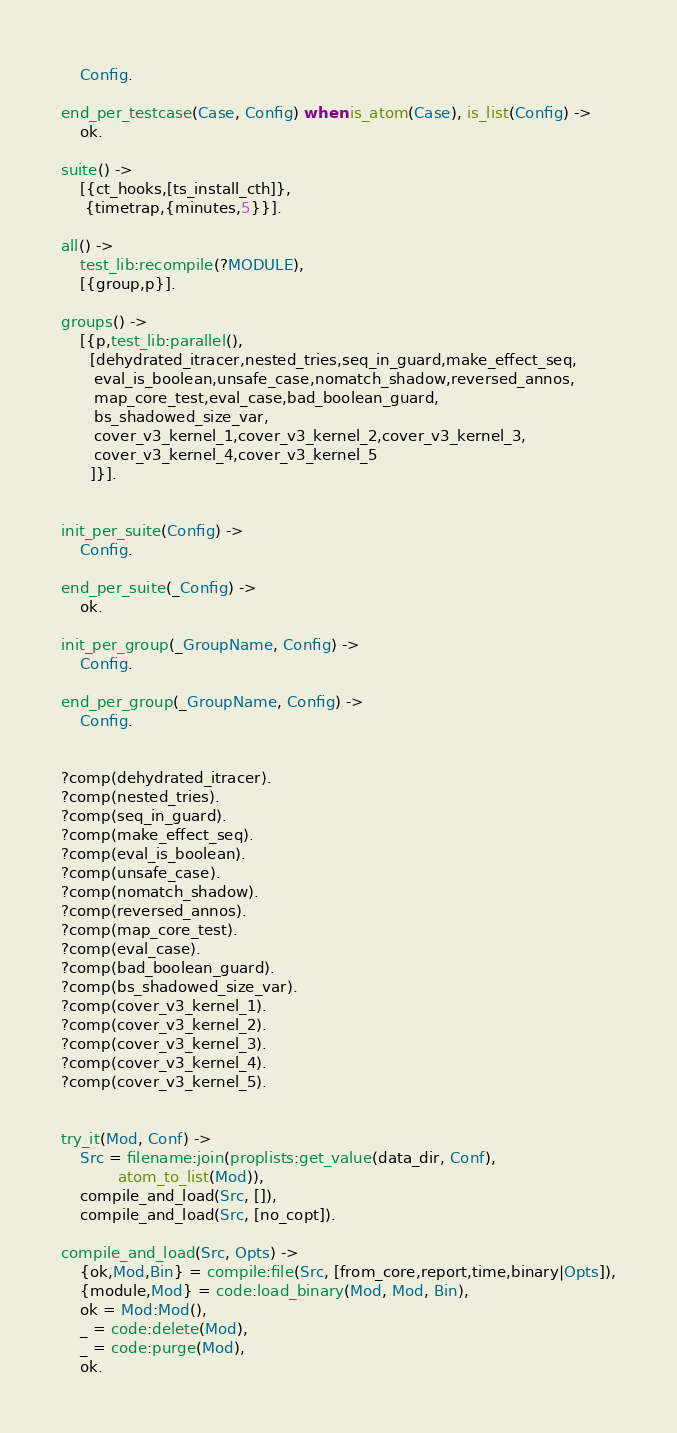Convert code to text. <code><loc_0><loc_0><loc_500><loc_500><_Erlang_>    Config.

end_per_testcase(Case, Config) when is_atom(Case), is_list(Config) ->
    ok.

suite() ->
    [{ct_hooks,[ts_install_cth]},
     {timetrap,{minutes,5}}].

all() -> 
    test_lib:recompile(?MODULE),
    [{group,p}].

groups() -> 
    [{p,test_lib:parallel(),
      [dehydrated_itracer,nested_tries,seq_in_guard,make_effect_seq,
       eval_is_boolean,unsafe_case,nomatch_shadow,reversed_annos,
       map_core_test,eval_case,bad_boolean_guard,
       bs_shadowed_size_var,
       cover_v3_kernel_1,cover_v3_kernel_2,cover_v3_kernel_3,
       cover_v3_kernel_4,cover_v3_kernel_5
      ]}].


init_per_suite(Config) ->
    Config.

end_per_suite(_Config) ->
    ok.

init_per_group(_GroupName, Config) ->
    Config.

end_per_group(_GroupName, Config) ->
    Config.


?comp(dehydrated_itracer).
?comp(nested_tries).
?comp(seq_in_guard).
?comp(make_effect_seq).
?comp(eval_is_boolean).
?comp(unsafe_case).
?comp(nomatch_shadow).
?comp(reversed_annos).
?comp(map_core_test).
?comp(eval_case).
?comp(bad_boolean_guard).
?comp(bs_shadowed_size_var).
?comp(cover_v3_kernel_1).
?comp(cover_v3_kernel_2).
?comp(cover_v3_kernel_3).
?comp(cover_v3_kernel_4).
?comp(cover_v3_kernel_5).


try_it(Mod, Conf) ->
    Src = filename:join(proplists:get_value(data_dir, Conf),
			atom_to_list(Mod)),
    compile_and_load(Src, []),
    compile_and_load(Src, [no_copt]).

compile_and_load(Src, Opts) ->
    {ok,Mod,Bin} = compile:file(Src, [from_core,report,time,binary|Opts]),
    {module,Mod} = code:load_binary(Mod, Mod, Bin),
    ok = Mod:Mod(),
    _ = code:delete(Mod),
    _ = code:purge(Mod),
    ok.
</code> 